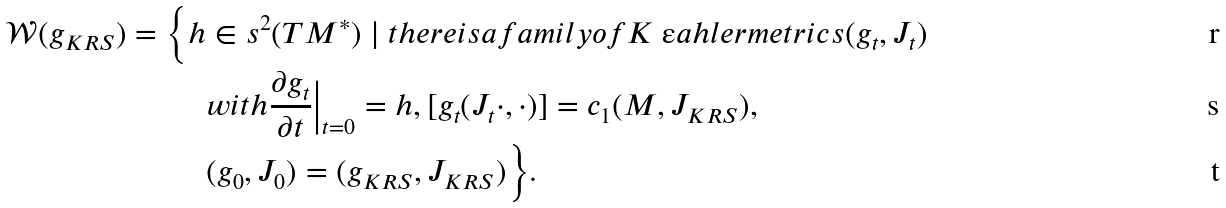<formula> <loc_0><loc_0><loc_500><loc_500>\mathcal { W } ( g _ { K R S } ) = \Big \{ h & \in s ^ { 2 } ( T M ^ { \ast } ) \ | \ t h e r e i s a f a m i l y o f K \ " a h l e r m e t r i c s ( g _ { t } , J _ { t } ) \\ & w i t h \frac { \partial g _ { t } } { \partial t } \Big | _ { t = 0 } = h , [ g _ { t } ( J _ { t } \cdot , \cdot ) ] = c _ { 1 } ( M , J _ { K R S } ) , \\ & ( g _ { 0 } , J _ { 0 } ) = ( g _ { K R S } , J _ { K R S } ) \Big \} .</formula> 